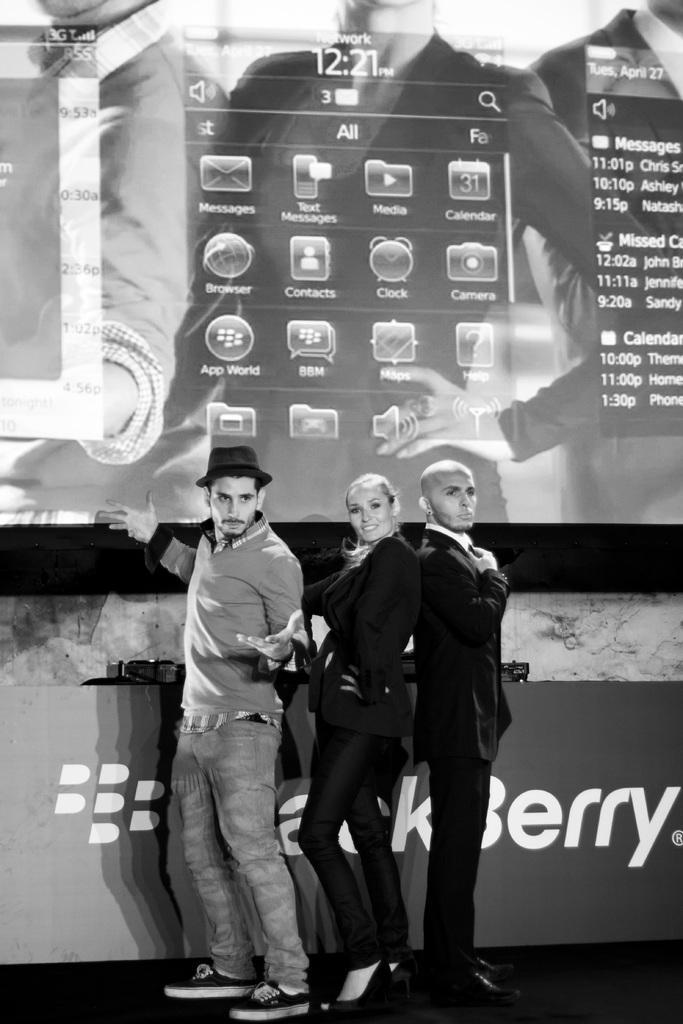In one or two sentences, can you explain what this image depicts? In this picture we can see people standing on the ground and in the background we can see a screen, wall, advertisement board and some objects. 